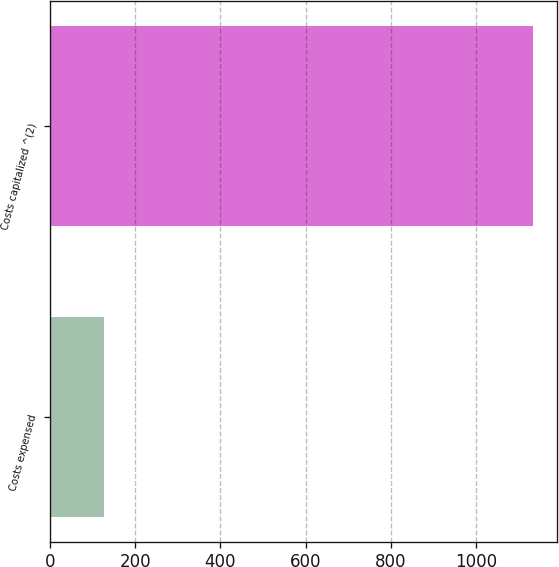Convert chart to OTSL. <chart><loc_0><loc_0><loc_500><loc_500><bar_chart><fcel>Costs expensed<fcel>Costs capitalized ^(2)<nl><fcel>126<fcel>1132<nl></chart> 